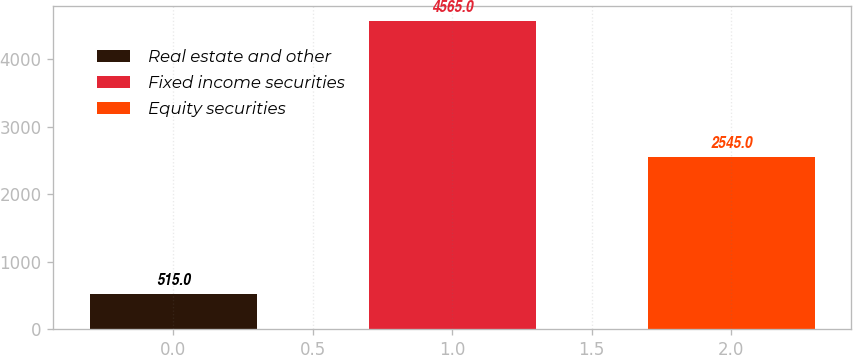<chart> <loc_0><loc_0><loc_500><loc_500><bar_chart><fcel>Real estate and other<fcel>Fixed income securities<fcel>Equity securities<nl><fcel>515<fcel>4565<fcel>2545<nl></chart> 